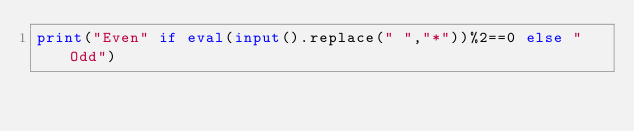<code> <loc_0><loc_0><loc_500><loc_500><_Python_>print("Even" if eval(input().replace(" ","*"))%2==0 else "Odd")</code> 